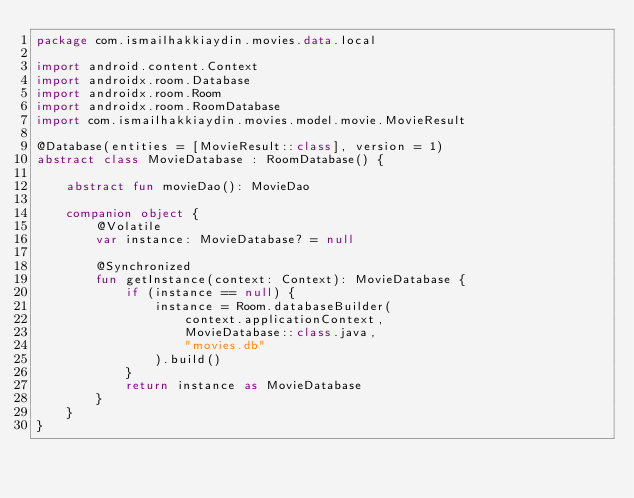<code> <loc_0><loc_0><loc_500><loc_500><_Kotlin_>package com.ismailhakkiaydin.movies.data.local

import android.content.Context
import androidx.room.Database
import androidx.room.Room
import androidx.room.RoomDatabase
import com.ismailhakkiaydin.movies.model.movie.MovieResult

@Database(entities = [MovieResult::class], version = 1)
abstract class MovieDatabase : RoomDatabase() {

    abstract fun movieDao(): MovieDao

    companion object {
        @Volatile
        var instance: MovieDatabase? = null

        @Synchronized
        fun getInstance(context: Context): MovieDatabase {
            if (instance == null) {
                instance = Room.databaseBuilder(
                    context.applicationContext,
                    MovieDatabase::class.java,
                    "movies.db"
                ).build()
            }
            return instance as MovieDatabase
        }
    }
}</code> 